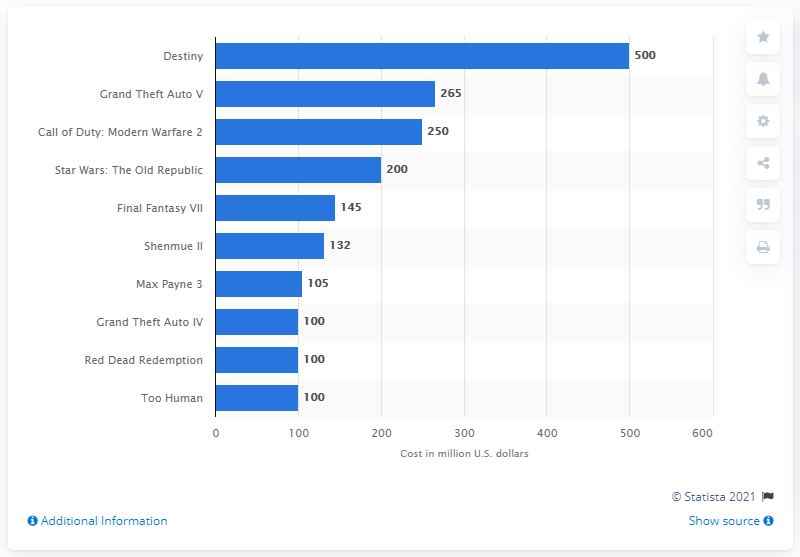List a handful of essential elements in this visual. The most expensive video game to date is Destiny. Bungie and Activision invested approximately $500 million in the development and marketing of Destiny. 